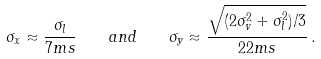<formula> <loc_0><loc_0><loc_500><loc_500>\sigma _ { x } \approx \frac { \sigma _ { l } } { 7 m s } \quad a n d \quad \sigma _ { y } \approx \frac { \sqrt { ( 2 \sigma _ { v } ^ { 2 } + \sigma _ { l } ^ { 2 } ) / 3 } } { 2 2 m s } \, .</formula> 